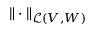<formula> <loc_0><loc_0><loc_500><loc_500>\| \cdot \| _ { \mathcal { L } ( V , W ) }</formula> 